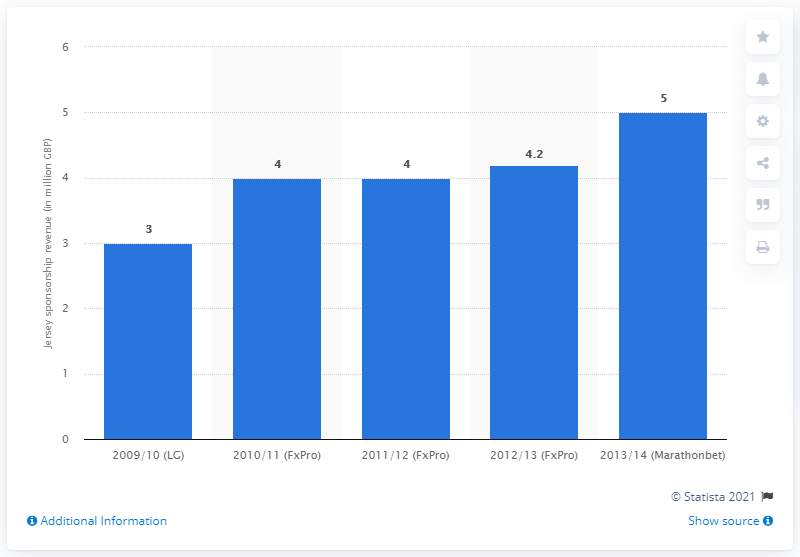Highlight a few significant elements in this photo. Fulham FC received 4.2 million dollars from its jersey sponsor in the 2012/13 season. 